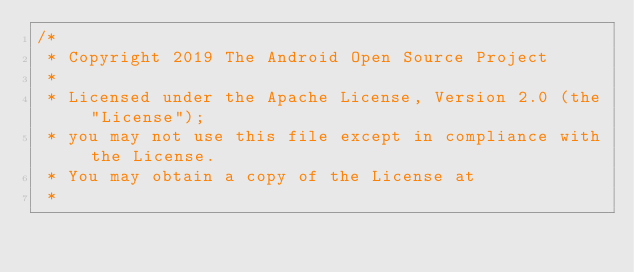Convert code to text. <code><loc_0><loc_0><loc_500><loc_500><_Kotlin_>/*
 * Copyright 2019 The Android Open Source Project
 *
 * Licensed under the Apache License, Version 2.0 (the "License");
 * you may not use this file except in compliance with the License.
 * You may obtain a copy of the License at
 *</code> 